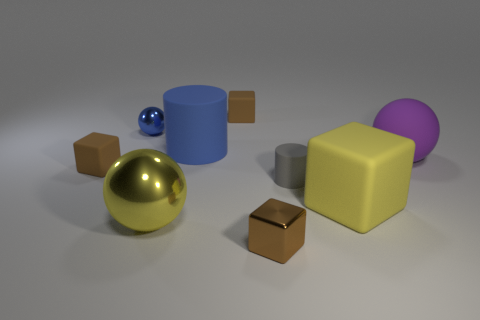What material is the tiny blue object that is the same shape as the purple rubber object?
Provide a short and direct response. Metal. How many gray things are either matte cylinders or large metallic spheres?
Your response must be concise. 1. Are there any other things of the same color as the big block?
Offer a terse response. Yes. What color is the tiny thing that is behind the metallic sphere that is behind the big purple matte sphere?
Offer a terse response. Brown. Are there fewer tiny metal spheres that are left of the yellow shiny sphere than blue matte things left of the gray rubber cylinder?
Offer a very short reply. No. What material is the thing that is the same color as the tiny sphere?
Your answer should be very brief. Rubber. What number of things are balls in front of the gray cylinder or big cyan rubber things?
Offer a very short reply. 1. There is a sphere that is in front of the purple rubber thing; does it have the same size as the matte ball?
Ensure brevity in your answer.  Yes. Is the number of yellow objects that are behind the blue cylinder less than the number of big purple cylinders?
Your response must be concise. No. What material is the yellow sphere that is the same size as the yellow matte object?
Your response must be concise. Metal. 